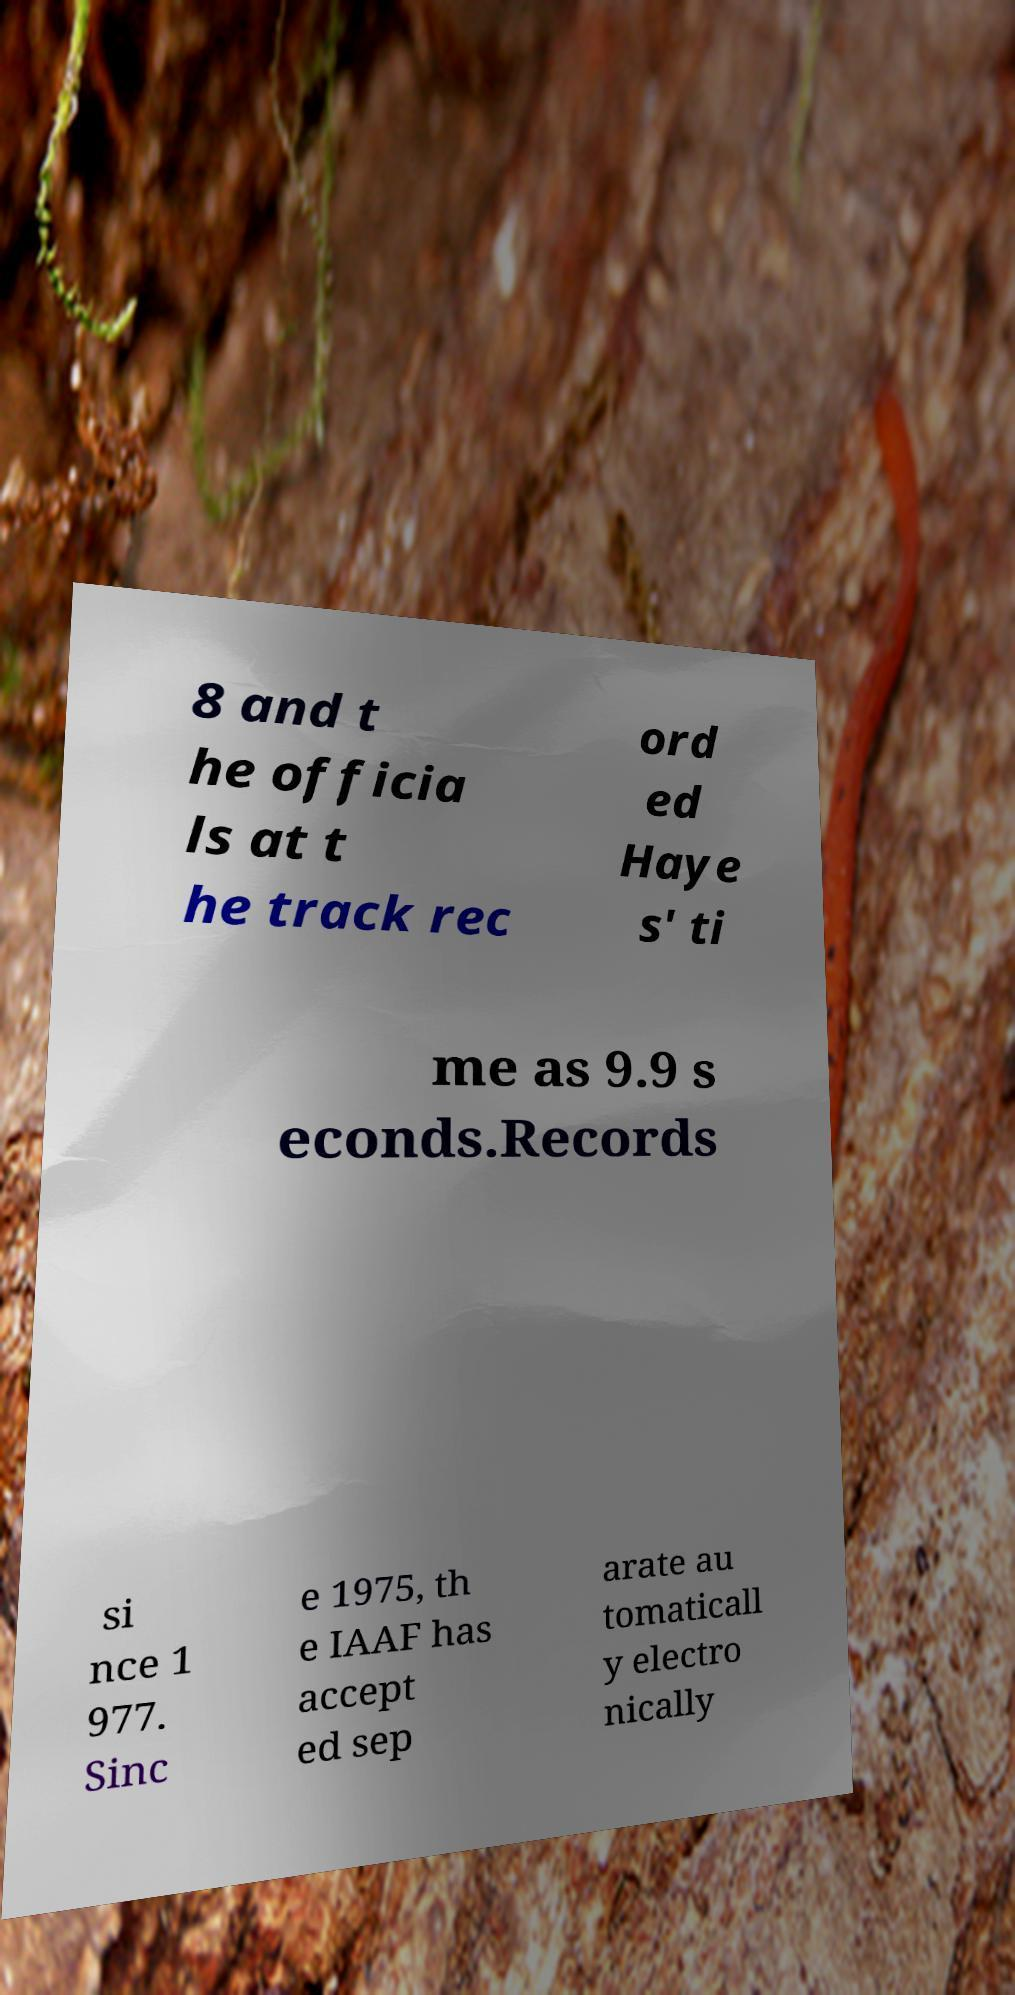Could you extract and type out the text from this image? 8 and t he officia ls at t he track rec ord ed Haye s' ti me as 9.9 s econds.Records si nce 1 977. Sinc e 1975, th e IAAF has accept ed sep arate au tomaticall y electro nically 